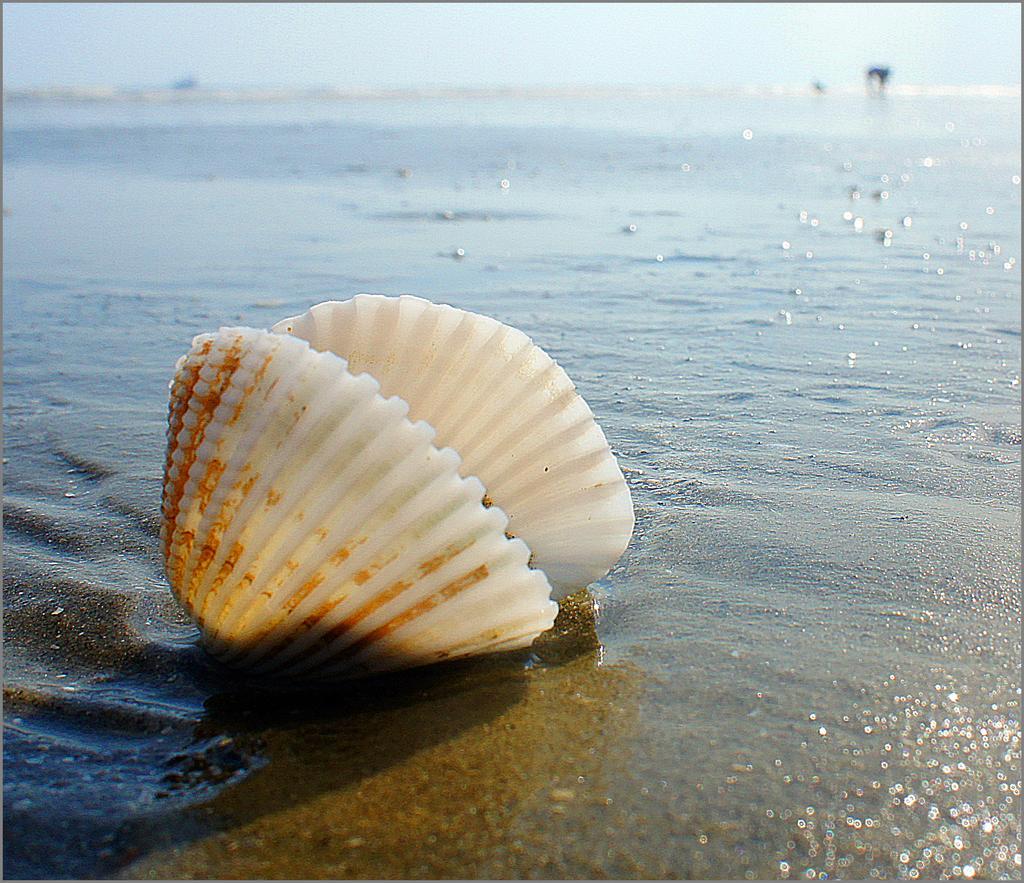Could you give a brief overview of what you see in this image? In this image I can see a shell. In the background, I can see the water. 